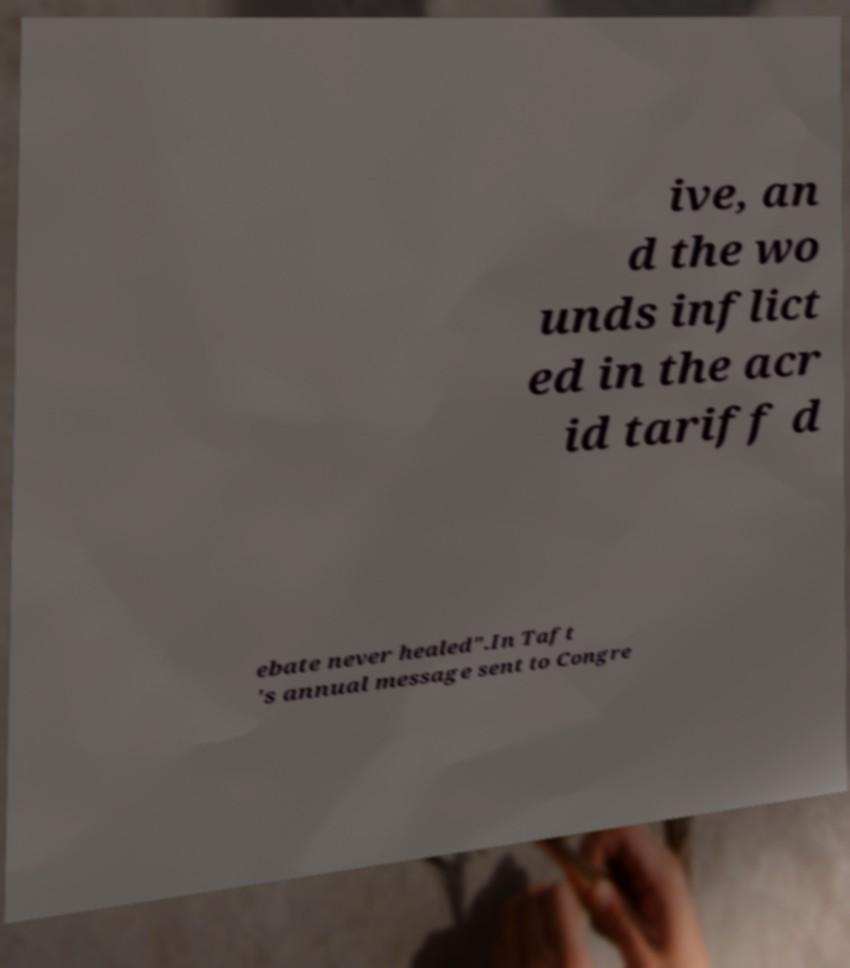Could you extract and type out the text from this image? ive, an d the wo unds inflict ed in the acr id tariff d ebate never healed".In Taft 's annual message sent to Congre 